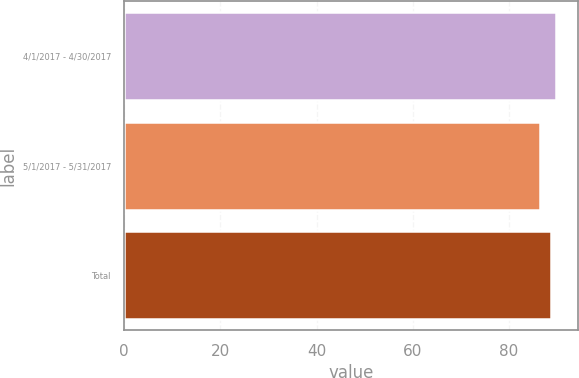Convert chart to OTSL. <chart><loc_0><loc_0><loc_500><loc_500><bar_chart><fcel>4/1/2017 - 4/30/2017<fcel>5/1/2017 - 5/31/2017<fcel>Total<nl><fcel>89.8<fcel>86.39<fcel>88.8<nl></chart> 